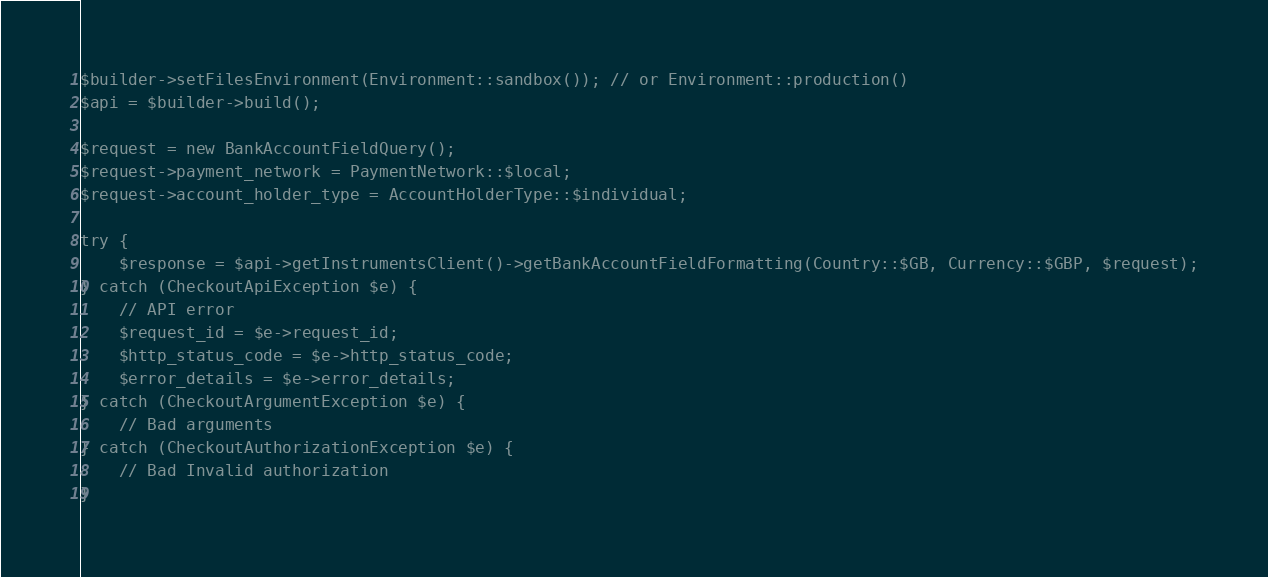Convert code to text. <code><loc_0><loc_0><loc_500><loc_500><_PHP_>$builder->setFilesEnvironment(Environment::sandbox()); // or Environment::production()
$api = $builder->build();

$request = new BankAccountFieldQuery();
$request->payment_network = PaymentNetwork::$local;
$request->account_holder_type = AccountHolderType::$individual;

try {
    $response = $api->getInstrumentsClient()->getBankAccountFieldFormatting(Country::$GB, Currency::$GBP, $request);
} catch (CheckoutApiException $e) {
    // API error
    $request_id = $e->request_id;
    $http_status_code = $e->http_status_code;
    $error_details = $e->error_details;
} catch (CheckoutArgumentException $e) {
    // Bad arguments
} catch (CheckoutAuthorizationException $e) {
    // Bad Invalid authorization
}
</code> 